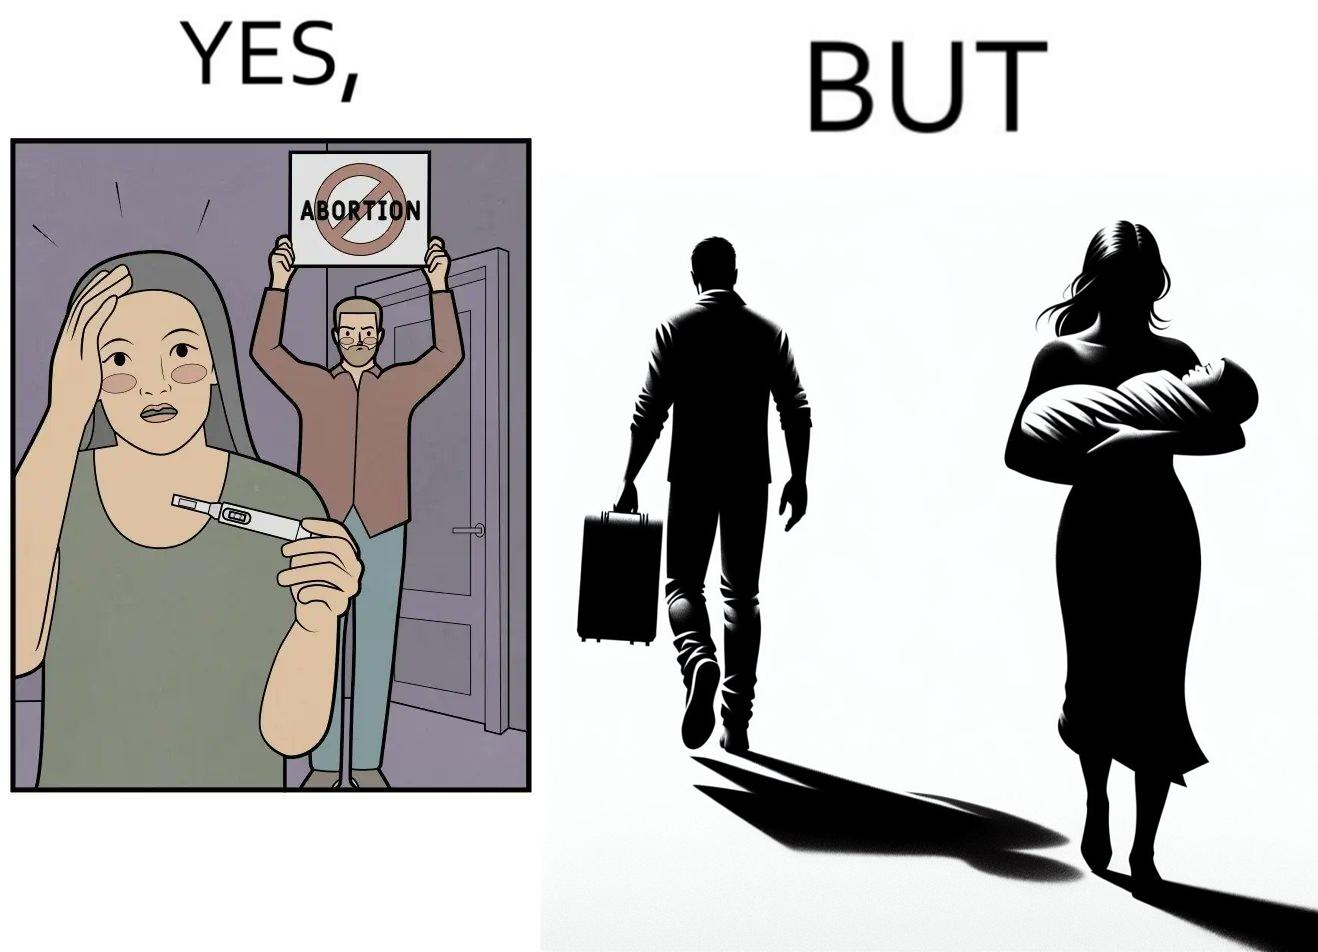Provide a description of this image. The images are ironic, since they show how men protest against abortion of babies but they choose to leave instead of taking care of the babies once they are born leaving the mother with neither a choice or support for raising a child 